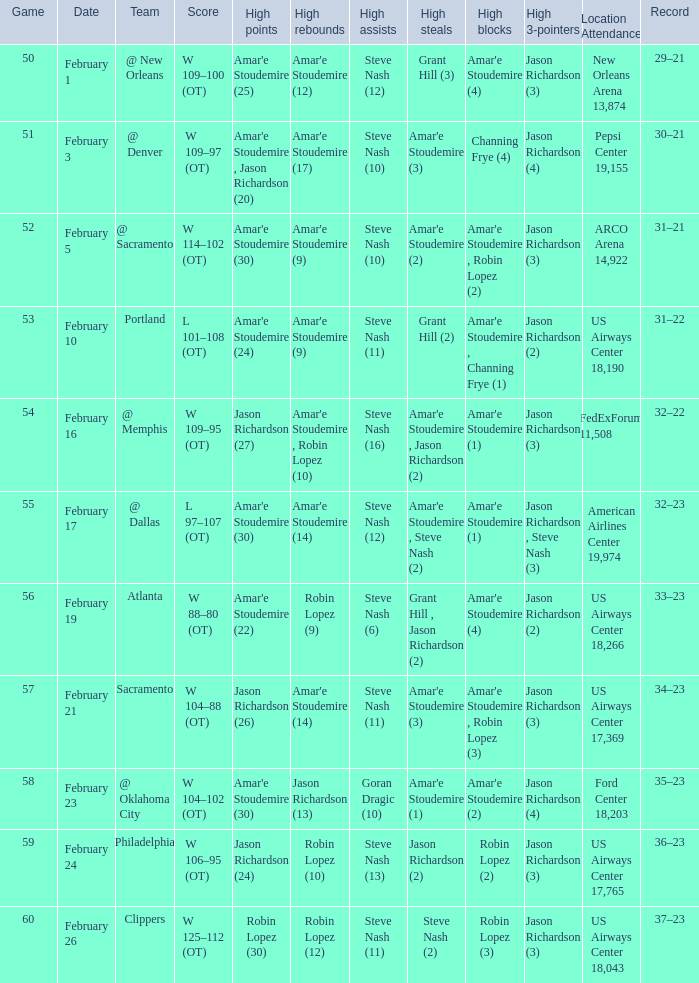Name the high points for pepsi center 19,155 Amar'e Stoudemire , Jason Richardson (20). 